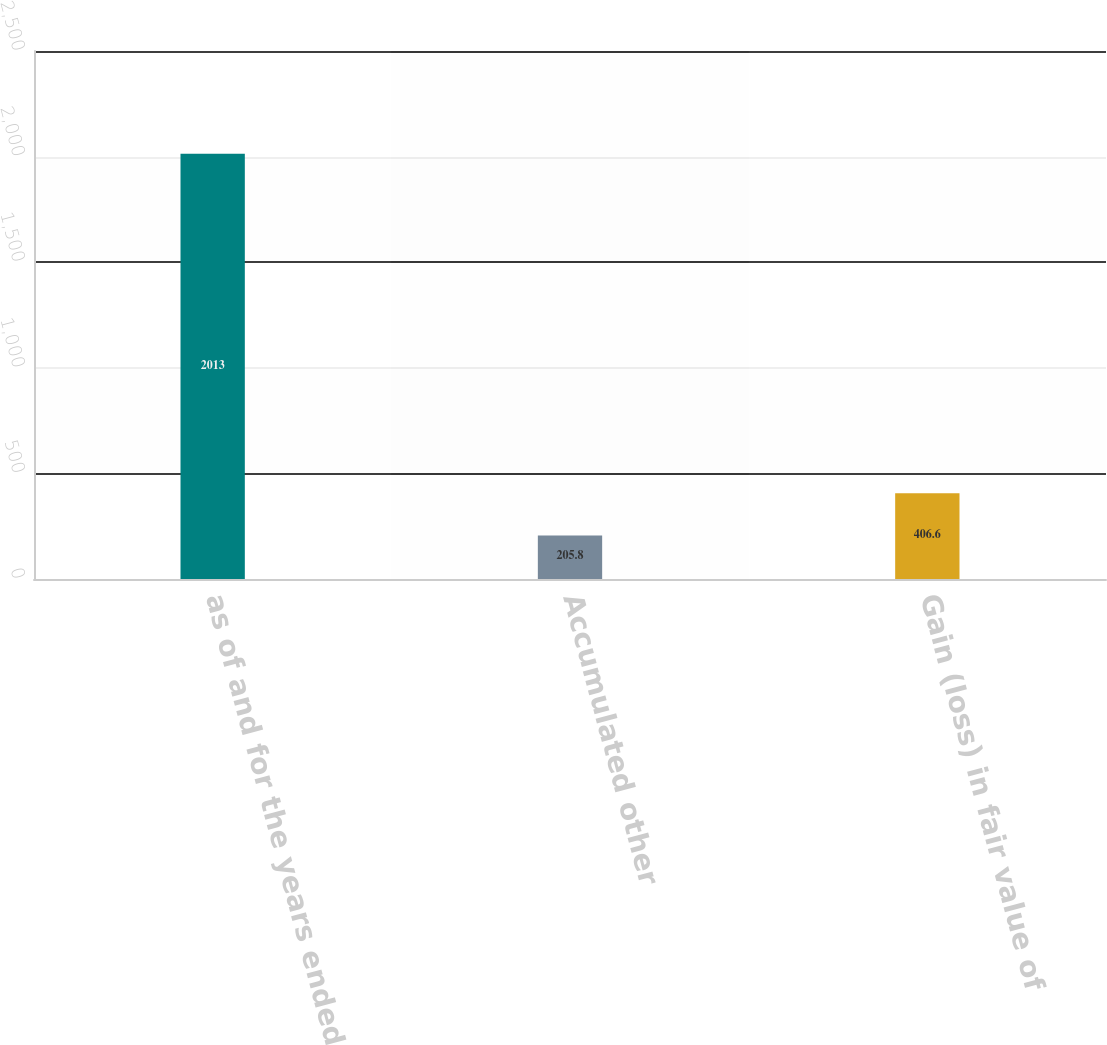Convert chart. <chart><loc_0><loc_0><loc_500><loc_500><bar_chart><fcel>as of and for the years ended<fcel>Accumulated other<fcel>Gain (loss) in fair value of<nl><fcel>2013<fcel>205.8<fcel>406.6<nl></chart> 